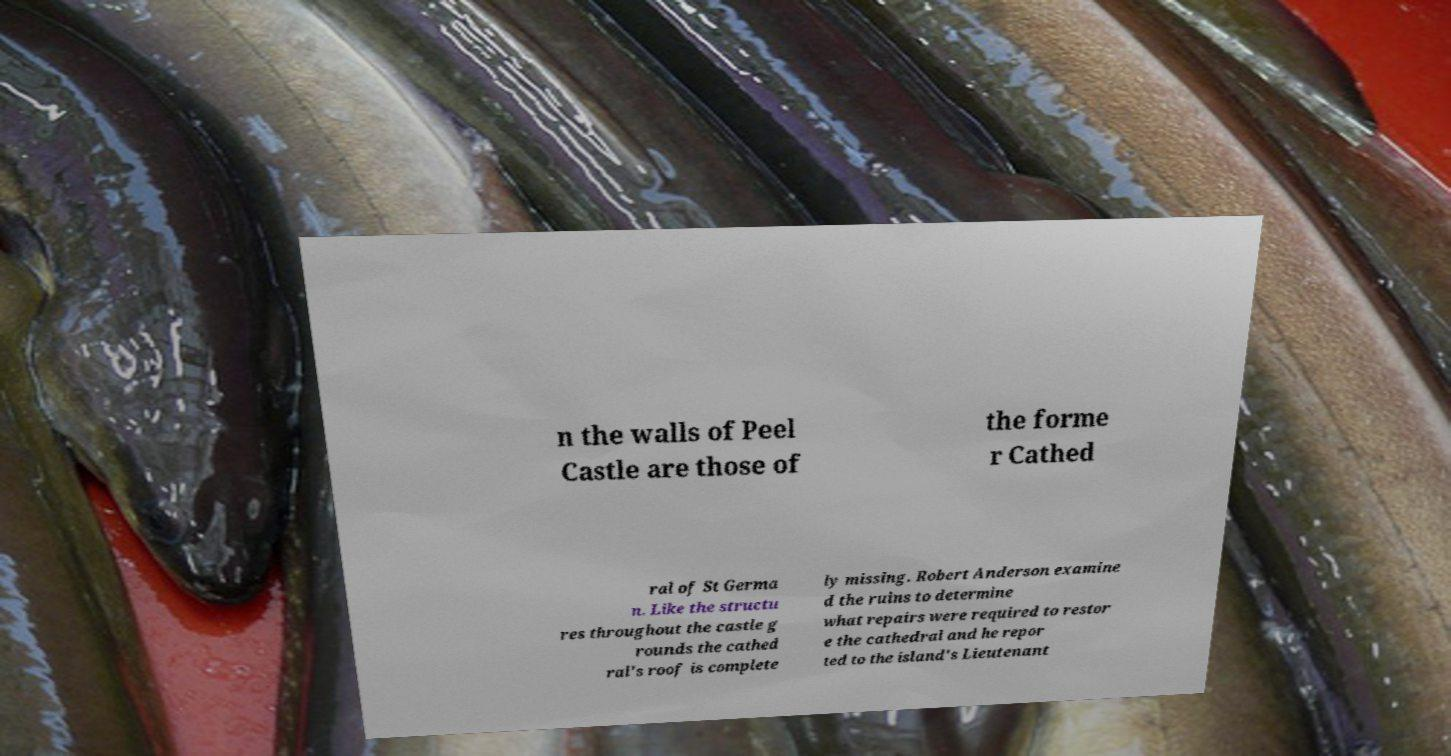There's text embedded in this image that I need extracted. Can you transcribe it verbatim? n the walls of Peel Castle are those of the forme r Cathed ral of St Germa n. Like the structu res throughout the castle g rounds the cathed ral's roof is complete ly missing. Robert Anderson examine d the ruins to determine what repairs were required to restor e the cathedral and he repor ted to the island's Lieutenant 